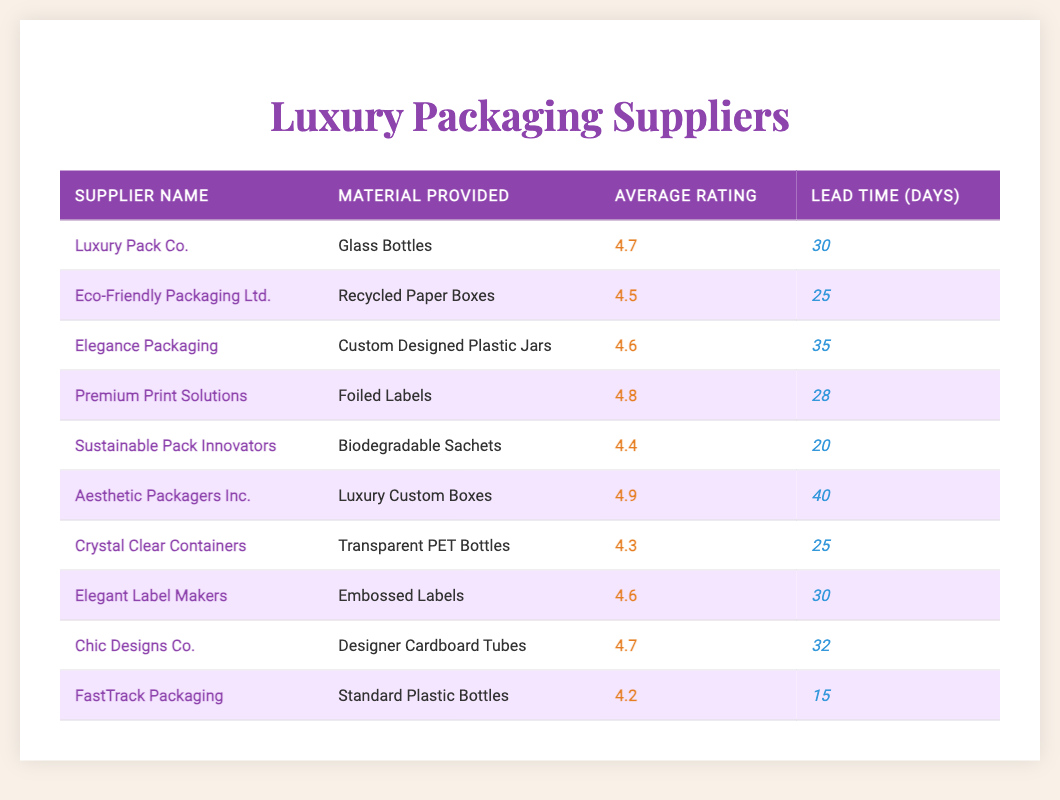What is the average rating of Eco-Friendly Packaging Ltd.? The table shows that the average rating for Eco-Friendly Packaging Ltd. is listed as 4.5.
Answer: 4.5 Which supplier has the highest average rating? Aesthetic Packagers Inc. has the highest average rating, which is 4.9.
Answer: Aesthetic Packagers Inc Is the lead time for FastTrack Packaging less than 20 days? The lead time for FastTrack Packaging is 15 days, which is less than 20 days.
Answer: Yes How many suppliers provide materials with an average rating of 4.6 or higher? The suppliers with an average rating of 4.6 or higher are Luxury Pack Co., Elegance Packaging, Premium Print Solutions, Aesthetic Packagers Inc., Elegant Label Makers, and Chic Designs Co. That totals 6 suppliers.
Answer: 6 What is the difference in lead time between the supplier with the shortest lead time and the supplier with the longest lead time? FastTrack Packaging has a lead time of 15 days (the shortest), and Aesthetic Packagers Inc. has a lead time of 40 days (the longest). The difference is calculated as 40 - 15 = 25 days.
Answer: 25 days Are there any suppliers that provide biodegradable materials? Yes, Sustainable Pack Innovators provides biodegradable sachets.
Answer: Yes What is the average lead time among all suppliers listed? The total lead time across all suppliers is 30 + 25 + 35 + 28 + 20 + 40 + 25 + 30 + 32 + 15 =  330 days. Dividing this by the 10 suppliers gives an average lead time of 330 / 10 = 33 days.
Answer: 33 days Which two suppliers provide materials with an average rating below 4.5? The suppliers with an average rating below 4.5 are Sustainable Pack Innovators (4.4) and FastTrack Packaging (4.2).
Answer: Sustainable Pack Innovators and FastTrack Packaging How many boxes do the suppliers provide in total? The suppliers provide a total of 3 types of boxes: Recycled Paper Boxes, Luxury Custom Boxes, and the Designer Cardboard Tubes representing 3 different box styles.
Answer: 3 types of boxes 